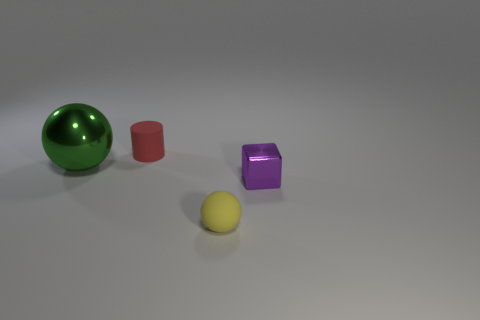Is there anything else that has the same shape as the red thing?
Your response must be concise. No. What is the material of the other thing that is the same shape as the big thing?
Provide a short and direct response. Rubber. What number of spheres are either big green objects or tiny purple things?
Keep it short and to the point. 1. What number of tiny purple blocks are the same material as the tiny yellow thing?
Offer a very short reply. 0. Are the small object to the right of the small yellow rubber object and the sphere behind the yellow rubber sphere made of the same material?
Ensure brevity in your answer.  Yes. How many rubber balls are to the left of the tiny red matte cylinder behind the object in front of the purple block?
Keep it short and to the point. 0. Is there any other thing that has the same color as the large metallic thing?
Give a very brief answer. No. The thing that is on the right side of the tiny rubber thing that is in front of the tiny matte cylinder is what color?
Your response must be concise. Purple. Are any blue objects visible?
Offer a very short reply. No. What is the color of the object that is both behind the purple metal block and to the right of the big metallic object?
Your answer should be compact. Red. 